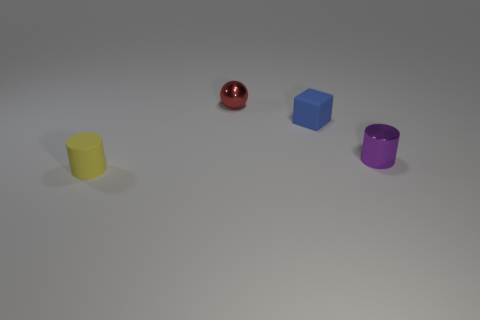Add 3 yellow rubber objects. How many objects exist? 7 Add 4 small yellow cylinders. How many small yellow cylinders are left? 5 Add 4 tiny purple objects. How many tiny purple objects exist? 5 Subtract 0 blue cylinders. How many objects are left? 4 Subtract all cubes. How many objects are left? 3 Subtract all big gray balls. Subtract all small cylinders. How many objects are left? 2 